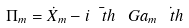Convert formula to latex. <formula><loc_0><loc_0><loc_500><loc_500>\Pi _ { m } = \dot { X } _ { m } - i \bar { \ t h } \ G a _ { m } \dot { \ t h }</formula> 